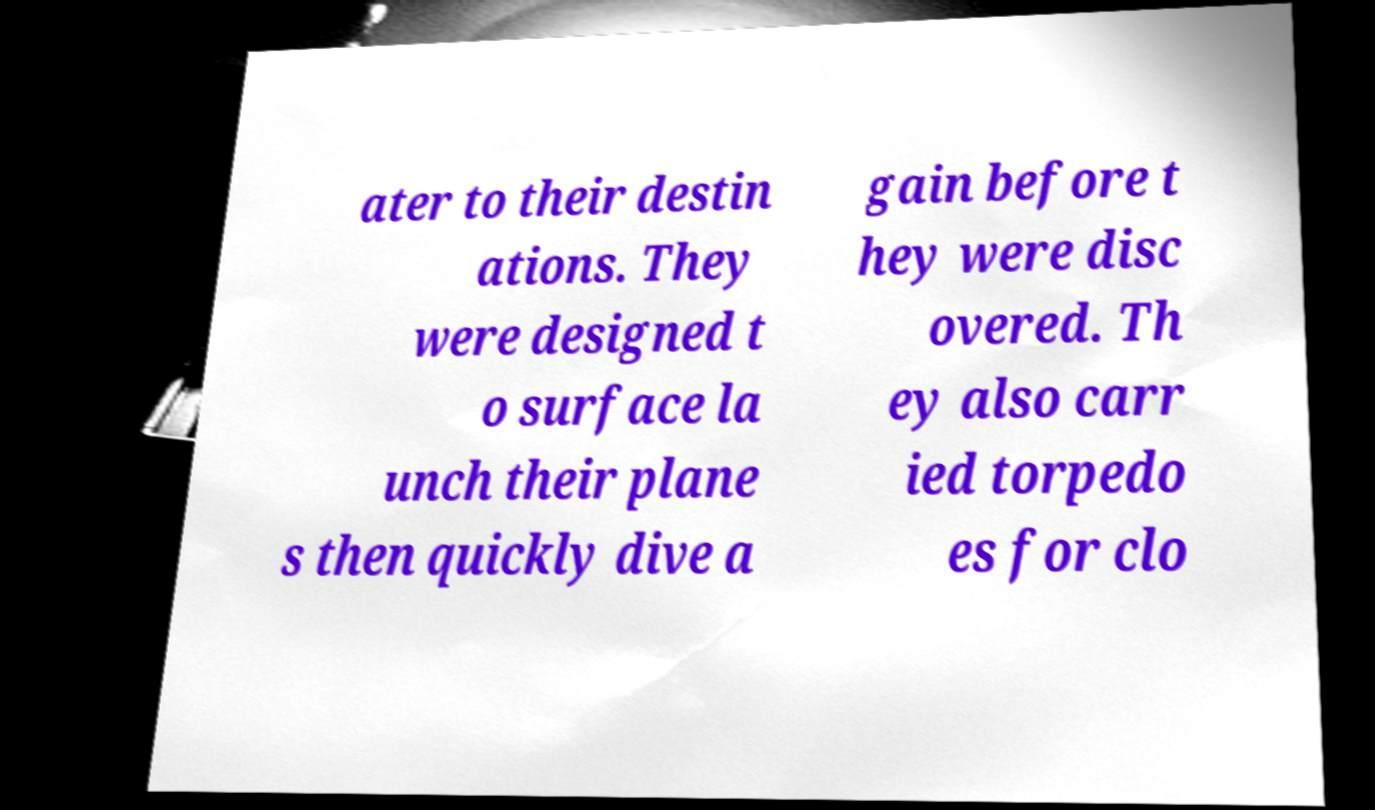Could you assist in decoding the text presented in this image and type it out clearly? ater to their destin ations. They were designed t o surface la unch their plane s then quickly dive a gain before t hey were disc overed. Th ey also carr ied torpedo es for clo 